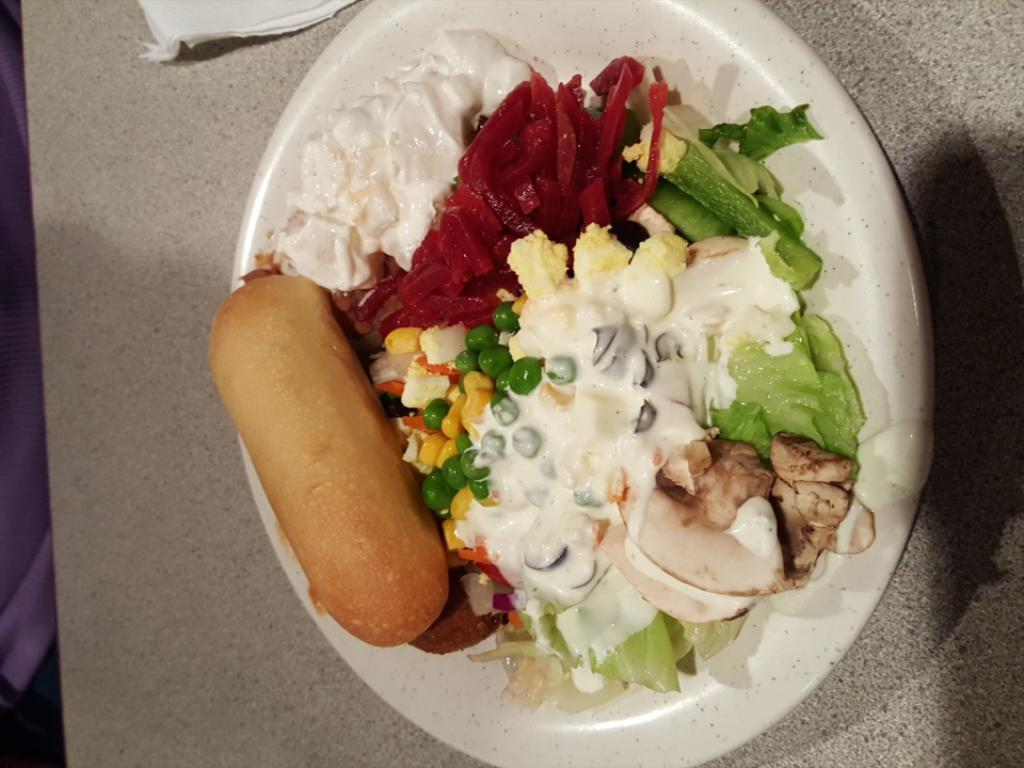What is the main subject of the image? The main subject of the image is food served on a bowl. Where is the bowl located in the image? The bowl is placed on a table. What else can be seen on the table beside the bowl? There is a tissue beside the bowl on the table. What type of pie is being served on the crib in the image? There is no pie or crib present in the image. The image features food served on a bowl placed on a table, with a tissue beside it. 